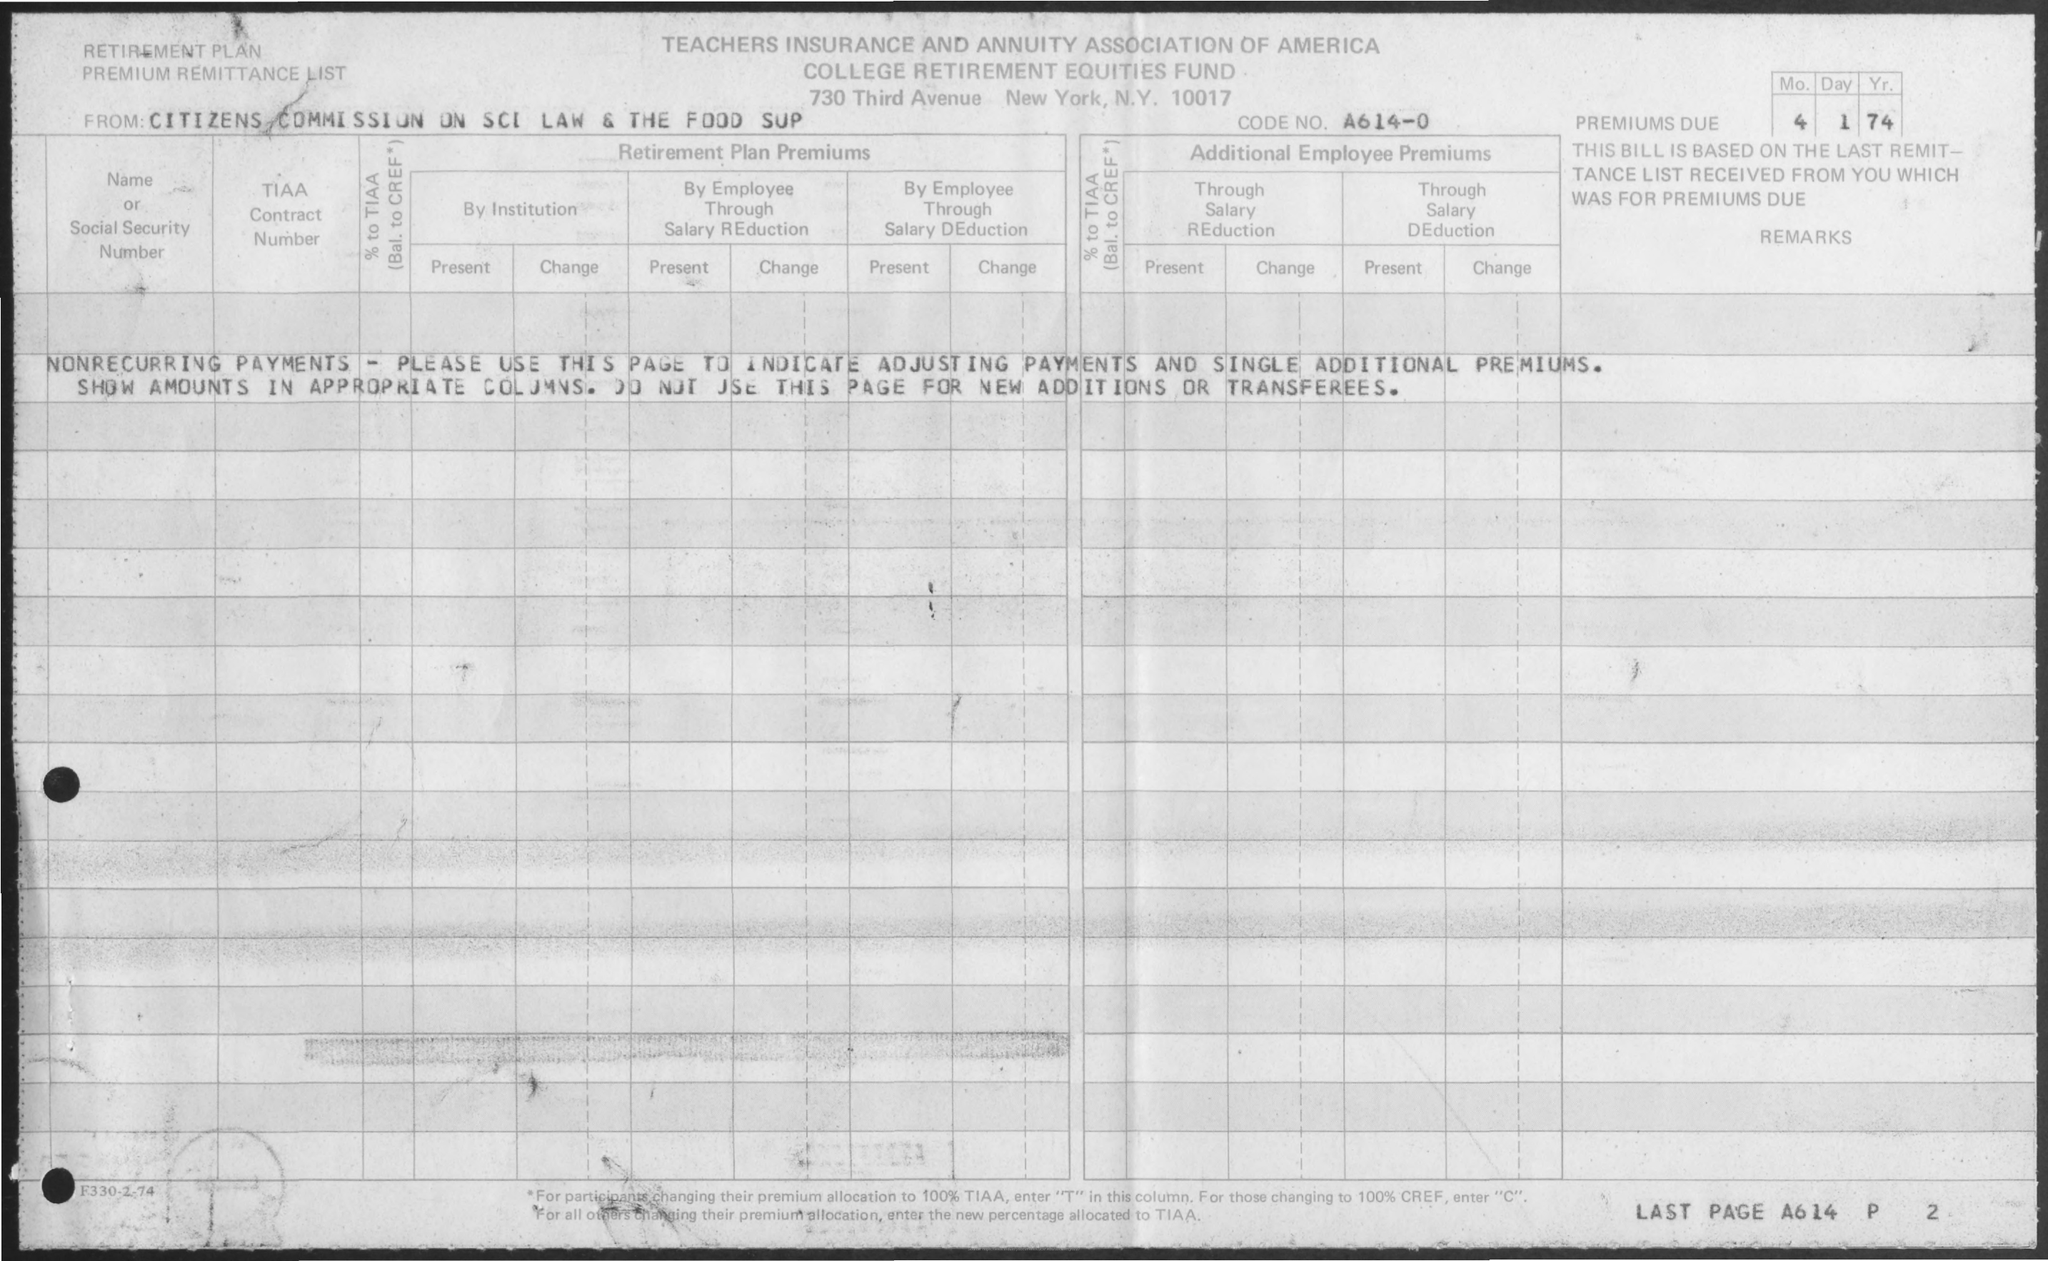What is the Code No.?
Offer a terse response. A614-0. When is the Premium Due?
Give a very brief answer. 4 1 74. 